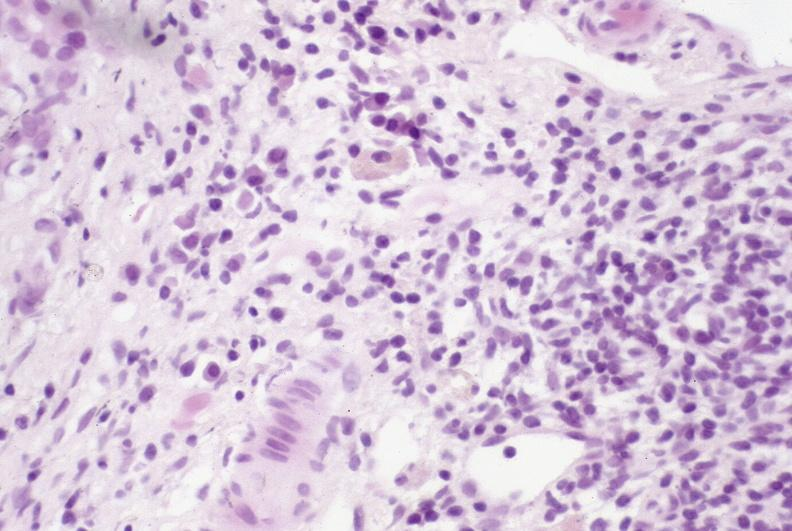s hepatobiliary present?
Answer the question using a single word or phrase. Yes 